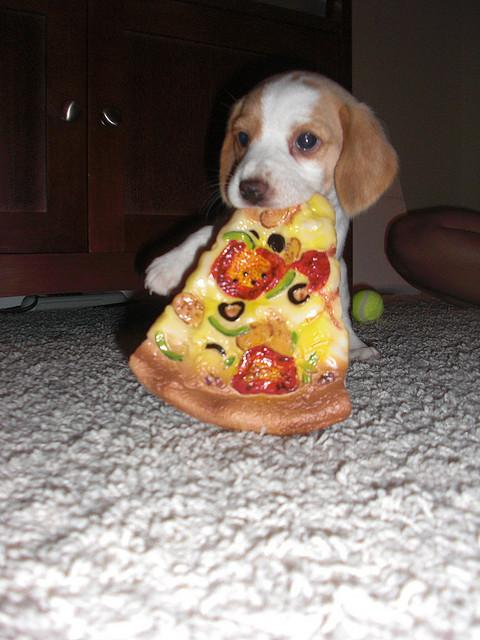What is the dog doing with the thing in its mouth? Please explain your reasoning. playing. The dog seems to be eating the slice of pizza shown here. 